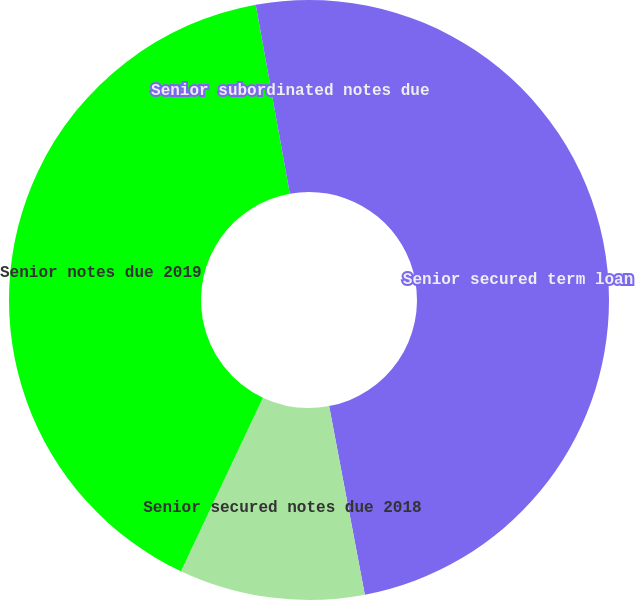Convert chart to OTSL. <chart><loc_0><loc_0><loc_500><loc_500><pie_chart><fcel>Senior secured term loan<fcel>Senior secured notes due 2018<fcel>Senior notes due 2019<fcel>Senior subordinated notes due<nl><fcel>47.02%<fcel>10.0%<fcel>40.14%<fcel>2.84%<nl></chart> 